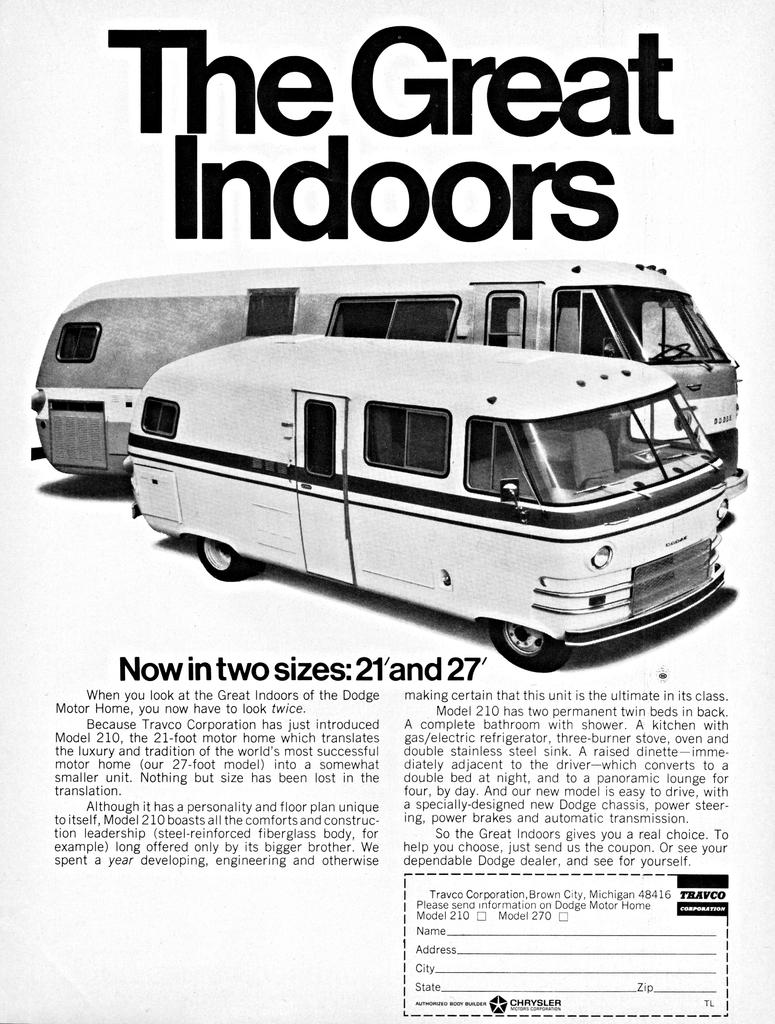<image>
Write a terse but informative summary of the picture. a black and white page ad for the travco corporation travel bus 